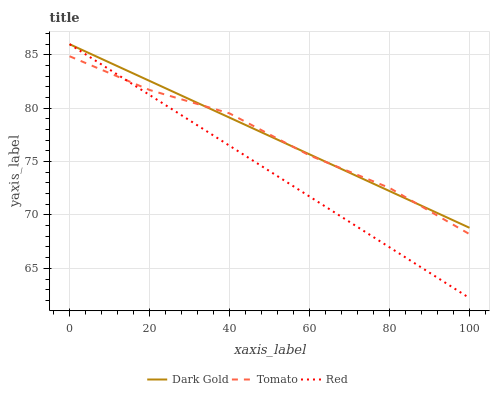Does Red have the minimum area under the curve?
Answer yes or no. Yes. Does Dark Gold have the maximum area under the curve?
Answer yes or no. Yes. Does Dark Gold have the minimum area under the curve?
Answer yes or no. No. Does Red have the maximum area under the curve?
Answer yes or no. No. Is Red the smoothest?
Answer yes or no. Yes. Is Tomato the roughest?
Answer yes or no. Yes. Is Dark Gold the smoothest?
Answer yes or no. No. Is Dark Gold the roughest?
Answer yes or no. No. Does Dark Gold have the lowest value?
Answer yes or no. No. Does Dark Gold have the highest value?
Answer yes or no. Yes. Does Tomato intersect Dark Gold?
Answer yes or no. Yes. Is Tomato less than Dark Gold?
Answer yes or no. No. Is Tomato greater than Dark Gold?
Answer yes or no. No. 